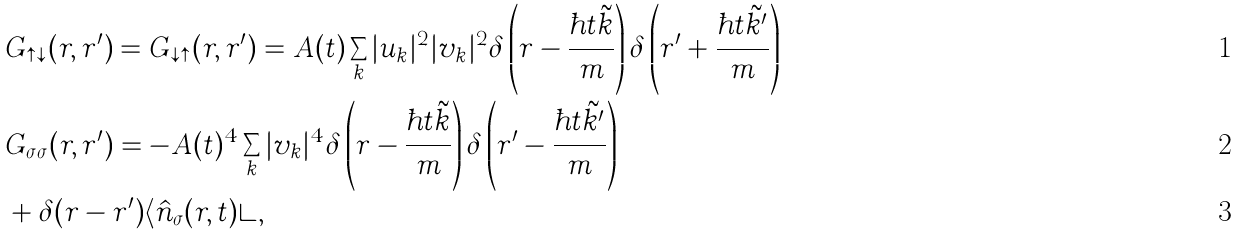Convert formula to latex. <formula><loc_0><loc_0><loc_500><loc_500>& G _ { \uparrow \downarrow } ( { r } , { r ^ { \prime } } ) = G _ { \downarrow \uparrow } ( { r } , { r ^ { \prime } } ) = A ( t ) \sum _ { k } | u _ { k } | ^ { 2 } | v _ { k } | ^ { 2 } \delta \left ( { r } - \frac { \hbar { t } \tilde { k } } { m } \right ) \delta \left ( { r ^ { \prime } } + \frac { \hbar { t } \tilde { k ^ { \prime } } } { m } \right ) \\ & G _ { \sigma \sigma } ( { r } , { r ^ { \prime } } ) = - A ( t ) ^ { 4 } \sum _ { k } | v _ { k } | ^ { 4 } \delta \left ( { r } - \frac { \hbar { t } \tilde { k } } { m } \right ) \delta \left ( { r ^ { \prime } } - \frac { \hbar { t } \tilde { k ^ { \prime } } } { m } \right ) \\ & + \delta ( { r } - { r ^ { \prime } } ) \langle \hat { n } _ { \sigma } ( { r } , t ) \rangle ,</formula> 